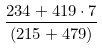Convert formula to latex. <formula><loc_0><loc_0><loc_500><loc_500>\frac { 2 3 4 + 4 1 9 \cdot 7 } { ( 2 1 5 + 4 7 9 ) }</formula> 